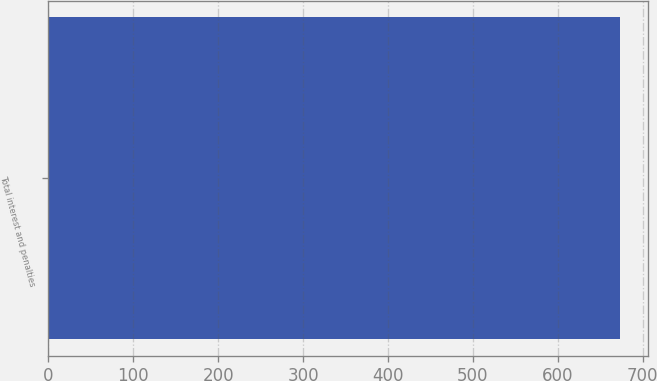<chart> <loc_0><loc_0><loc_500><loc_500><bar_chart><fcel>Total interest and penalties<nl><fcel>672.9<nl></chart> 